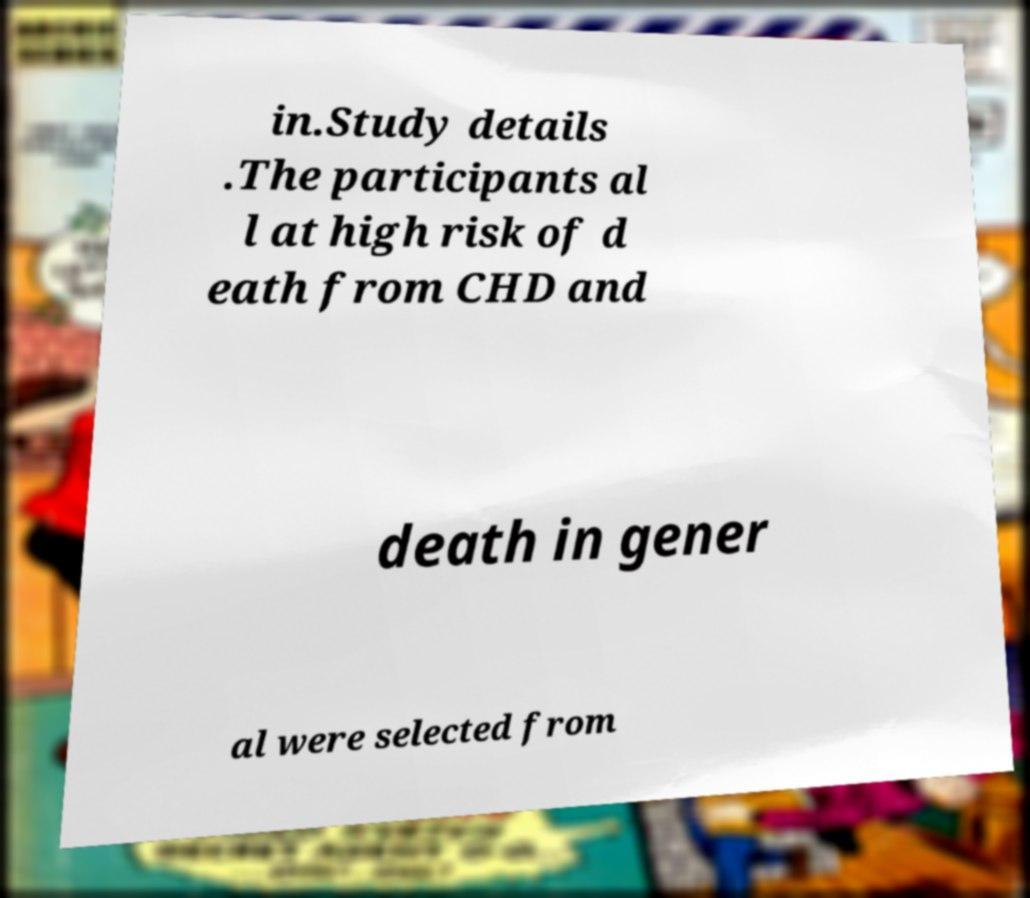Can you read and provide the text displayed in the image?This photo seems to have some interesting text. Can you extract and type it out for me? in.Study details .The participants al l at high risk of d eath from CHD and death in gener al were selected from 